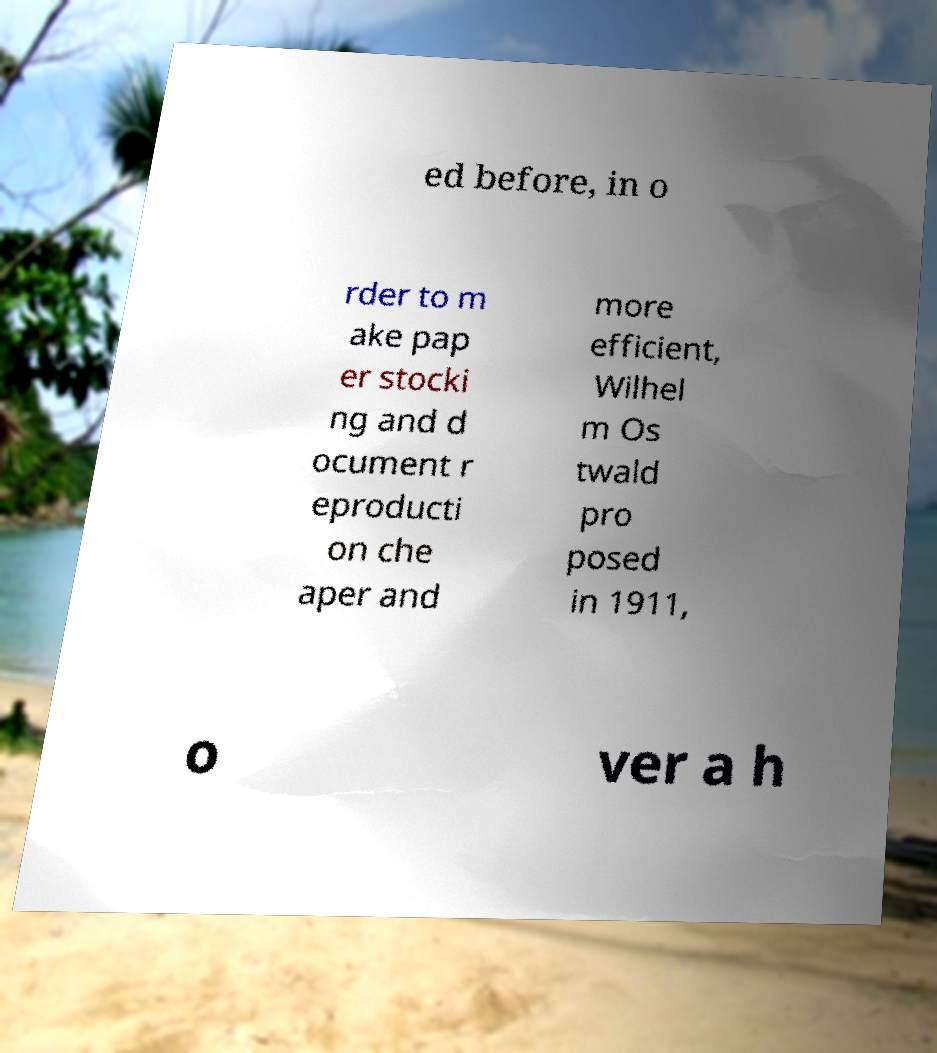I need the written content from this picture converted into text. Can you do that? ed before, in o rder to m ake pap er stocki ng and d ocument r eproducti on che aper and more efficient, Wilhel m Os twald pro posed in 1911, o ver a h 